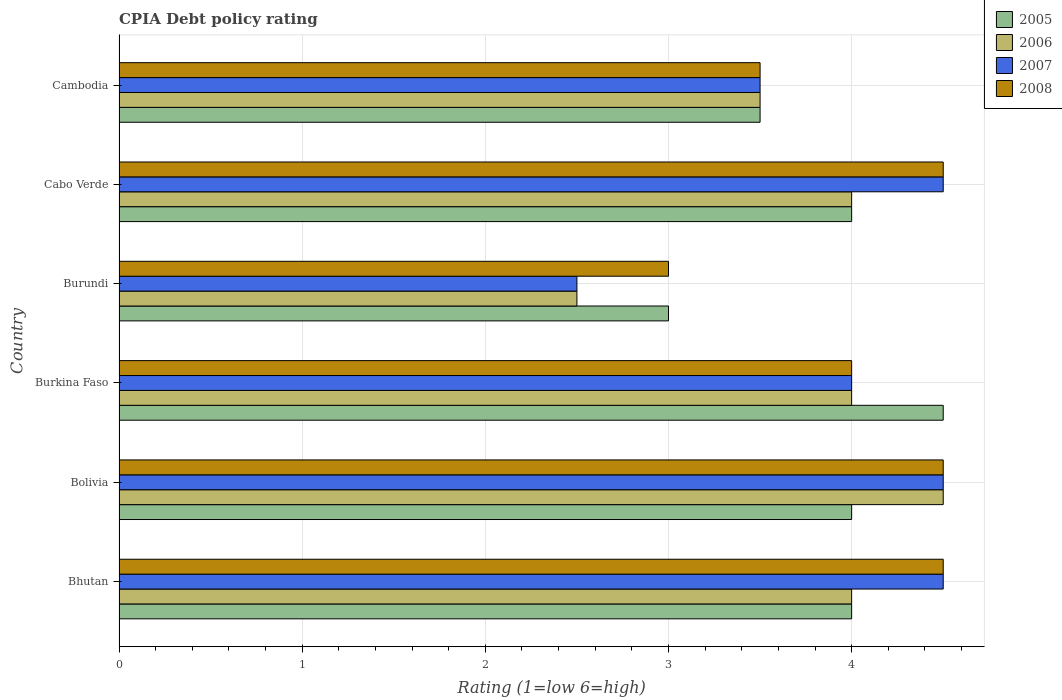How many different coloured bars are there?
Give a very brief answer. 4. Are the number of bars per tick equal to the number of legend labels?
Give a very brief answer. Yes. What is the label of the 1st group of bars from the top?
Give a very brief answer. Cambodia. In how many cases, is the number of bars for a given country not equal to the number of legend labels?
Give a very brief answer. 0. What is the CPIA rating in 2007 in Bolivia?
Keep it short and to the point. 4.5. Across all countries, what is the maximum CPIA rating in 2005?
Provide a short and direct response. 4.5. In which country was the CPIA rating in 2005 minimum?
Your answer should be compact. Burundi. What is the difference between the CPIA rating in 2008 in Burundi and that in Cambodia?
Ensure brevity in your answer.  -0.5. What is the difference between the CPIA rating in 2005 in Burundi and the CPIA rating in 2008 in Bolivia?
Make the answer very short. -1.5. What is the average CPIA rating in 2007 per country?
Ensure brevity in your answer.  3.92. What is the ratio of the CPIA rating in 2008 in Cabo Verde to that in Cambodia?
Your answer should be very brief. 1.29. Is the difference between the CPIA rating in 2008 in Bhutan and Burundi greater than the difference between the CPIA rating in 2007 in Bhutan and Burundi?
Your response must be concise. No. What is the difference between the highest and the lowest CPIA rating in 2005?
Offer a very short reply. 1.5. What does the 1st bar from the bottom in Burundi represents?
Your response must be concise. 2005. Is it the case that in every country, the sum of the CPIA rating in 2005 and CPIA rating in 2007 is greater than the CPIA rating in 2008?
Keep it short and to the point. Yes. Are all the bars in the graph horizontal?
Keep it short and to the point. Yes. Are the values on the major ticks of X-axis written in scientific E-notation?
Offer a very short reply. No. Where does the legend appear in the graph?
Your response must be concise. Top right. How are the legend labels stacked?
Offer a terse response. Vertical. What is the title of the graph?
Ensure brevity in your answer.  CPIA Debt policy rating. Does "2012" appear as one of the legend labels in the graph?
Your response must be concise. No. What is the label or title of the X-axis?
Offer a terse response. Rating (1=low 6=high). What is the Rating (1=low 6=high) in 2006 in Bhutan?
Offer a terse response. 4. What is the Rating (1=low 6=high) of 2007 in Bhutan?
Make the answer very short. 4.5. What is the Rating (1=low 6=high) of 2006 in Bolivia?
Make the answer very short. 4.5. What is the Rating (1=low 6=high) in 2007 in Bolivia?
Give a very brief answer. 4.5. What is the Rating (1=low 6=high) of 2008 in Bolivia?
Offer a terse response. 4.5. What is the Rating (1=low 6=high) in 2008 in Burkina Faso?
Make the answer very short. 4. What is the Rating (1=low 6=high) in 2005 in Burundi?
Give a very brief answer. 3. What is the Rating (1=low 6=high) in 2006 in Burundi?
Provide a succinct answer. 2.5. What is the Rating (1=low 6=high) of 2007 in Burundi?
Make the answer very short. 2.5. What is the Rating (1=low 6=high) in 2007 in Cabo Verde?
Provide a short and direct response. 4.5. What is the Rating (1=low 6=high) in 2008 in Cabo Verde?
Provide a short and direct response. 4.5. What is the Rating (1=low 6=high) of 2005 in Cambodia?
Offer a terse response. 3.5. What is the Rating (1=low 6=high) of 2006 in Cambodia?
Ensure brevity in your answer.  3.5. What is the Rating (1=low 6=high) in 2007 in Cambodia?
Keep it short and to the point. 3.5. What is the Rating (1=low 6=high) of 2008 in Cambodia?
Keep it short and to the point. 3.5. Across all countries, what is the maximum Rating (1=low 6=high) in 2007?
Make the answer very short. 4.5. Across all countries, what is the minimum Rating (1=low 6=high) of 2008?
Offer a terse response. 3. What is the total Rating (1=low 6=high) of 2007 in the graph?
Give a very brief answer. 23.5. What is the difference between the Rating (1=low 6=high) in 2005 in Bhutan and that in Bolivia?
Your answer should be compact. 0. What is the difference between the Rating (1=low 6=high) in 2006 in Bhutan and that in Bolivia?
Offer a very short reply. -0.5. What is the difference between the Rating (1=low 6=high) of 2005 in Bhutan and that in Burkina Faso?
Your answer should be very brief. -0.5. What is the difference between the Rating (1=low 6=high) in 2007 in Bhutan and that in Burkina Faso?
Offer a very short reply. 0.5. What is the difference between the Rating (1=low 6=high) of 2008 in Bhutan and that in Burkina Faso?
Your answer should be very brief. 0.5. What is the difference between the Rating (1=low 6=high) in 2005 in Bhutan and that in Burundi?
Ensure brevity in your answer.  1. What is the difference between the Rating (1=low 6=high) of 2008 in Bhutan and that in Burundi?
Give a very brief answer. 1.5. What is the difference between the Rating (1=low 6=high) in 2007 in Bhutan and that in Cabo Verde?
Your response must be concise. 0. What is the difference between the Rating (1=low 6=high) in 2006 in Bhutan and that in Cambodia?
Your answer should be very brief. 0.5. What is the difference between the Rating (1=low 6=high) of 2007 in Bolivia and that in Burkina Faso?
Your response must be concise. 0.5. What is the difference between the Rating (1=low 6=high) in 2008 in Bolivia and that in Burkina Faso?
Your response must be concise. 0.5. What is the difference between the Rating (1=low 6=high) in 2005 in Bolivia and that in Burundi?
Provide a short and direct response. 1. What is the difference between the Rating (1=low 6=high) of 2006 in Bolivia and that in Burundi?
Your response must be concise. 2. What is the difference between the Rating (1=low 6=high) of 2007 in Bolivia and that in Cabo Verde?
Keep it short and to the point. 0. What is the difference between the Rating (1=low 6=high) in 2008 in Bolivia and that in Cabo Verde?
Offer a very short reply. 0. What is the difference between the Rating (1=low 6=high) of 2007 in Bolivia and that in Cambodia?
Keep it short and to the point. 1. What is the difference between the Rating (1=low 6=high) in 2008 in Bolivia and that in Cambodia?
Provide a short and direct response. 1. What is the difference between the Rating (1=low 6=high) in 2007 in Burkina Faso and that in Burundi?
Provide a succinct answer. 1.5. What is the difference between the Rating (1=low 6=high) of 2006 in Burkina Faso and that in Cabo Verde?
Your answer should be compact. 0. What is the difference between the Rating (1=low 6=high) of 2008 in Burkina Faso and that in Cabo Verde?
Provide a short and direct response. -0.5. What is the difference between the Rating (1=low 6=high) in 2006 in Burkina Faso and that in Cambodia?
Provide a short and direct response. 0.5. What is the difference between the Rating (1=low 6=high) of 2007 in Burkina Faso and that in Cambodia?
Make the answer very short. 0.5. What is the difference between the Rating (1=low 6=high) of 2005 in Burundi and that in Cabo Verde?
Keep it short and to the point. -1. What is the difference between the Rating (1=low 6=high) in 2006 in Burundi and that in Cabo Verde?
Ensure brevity in your answer.  -1.5. What is the difference between the Rating (1=low 6=high) of 2007 in Burundi and that in Cabo Verde?
Provide a succinct answer. -2. What is the difference between the Rating (1=low 6=high) of 2008 in Burundi and that in Cabo Verde?
Your answer should be compact. -1.5. What is the difference between the Rating (1=low 6=high) of 2006 in Burundi and that in Cambodia?
Give a very brief answer. -1. What is the difference between the Rating (1=low 6=high) in 2008 in Burundi and that in Cambodia?
Ensure brevity in your answer.  -0.5. What is the difference between the Rating (1=low 6=high) in 2005 in Cabo Verde and that in Cambodia?
Provide a short and direct response. 0.5. What is the difference between the Rating (1=low 6=high) in 2007 in Cabo Verde and that in Cambodia?
Provide a short and direct response. 1. What is the difference between the Rating (1=low 6=high) in 2008 in Cabo Verde and that in Cambodia?
Your response must be concise. 1. What is the difference between the Rating (1=low 6=high) in 2006 in Bhutan and the Rating (1=low 6=high) in 2007 in Bolivia?
Provide a short and direct response. -0.5. What is the difference between the Rating (1=low 6=high) in 2007 in Bhutan and the Rating (1=low 6=high) in 2008 in Bolivia?
Your answer should be compact. 0. What is the difference between the Rating (1=low 6=high) in 2005 in Bhutan and the Rating (1=low 6=high) in 2006 in Burkina Faso?
Offer a terse response. 0. What is the difference between the Rating (1=low 6=high) in 2005 in Bhutan and the Rating (1=low 6=high) in 2007 in Burkina Faso?
Offer a very short reply. 0. What is the difference between the Rating (1=low 6=high) of 2006 in Bhutan and the Rating (1=low 6=high) of 2007 in Burkina Faso?
Offer a terse response. 0. What is the difference between the Rating (1=low 6=high) of 2007 in Bhutan and the Rating (1=low 6=high) of 2008 in Burkina Faso?
Keep it short and to the point. 0.5. What is the difference between the Rating (1=low 6=high) in 2005 in Bhutan and the Rating (1=low 6=high) in 2007 in Burundi?
Ensure brevity in your answer.  1.5. What is the difference between the Rating (1=low 6=high) in 2005 in Bhutan and the Rating (1=low 6=high) in 2008 in Burundi?
Give a very brief answer. 1. What is the difference between the Rating (1=low 6=high) of 2006 in Bhutan and the Rating (1=low 6=high) of 2007 in Burundi?
Give a very brief answer. 1.5. What is the difference between the Rating (1=low 6=high) of 2006 in Bhutan and the Rating (1=low 6=high) of 2008 in Burundi?
Provide a short and direct response. 1. What is the difference between the Rating (1=low 6=high) of 2007 in Bhutan and the Rating (1=low 6=high) of 2008 in Burundi?
Keep it short and to the point. 1.5. What is the difference between the Rating (1=low 6=high) of 2005 in Bhutan and the Rating (1=low 6=high) of 2006 in Cabo Verde?
Your answer should be compact. 0. What is the difference between the Rating (1=low 6=high) in 2006 in Bhutan and the Rating (1=low 6=high) in 2007 in Cabo Verde?
Your answer should be very brief. -0.5. What is the difference between the Rating (1=low 6=high) of 2006 in Bhutan and the Rating (1=low 6=high) of 2008 in Cabo Verde?
Give a very brief answer. -0.5. What is the difference between the Rating (1=low 6=high) in 2005 in Bhutan and the Rating (1=low 6=high) in 2006 in Cambodia?
Offer a very short reply. 0.5. What is the difference between the Rating (1=low 6=high) in 2005 in Bhutan and the Rating (1=low 6=high) in 2008 in Cambodia?
Make the answer very short. 0.5. What is the difference between the Rating (1=low 6=high) of 2007 in Bhutan and the Rating (1=low 6=high) of 2008 in Cambodia?
Offer a very short reply. 1. What is the difference between the Rating (1=low 6=high) of 2005 in Bolivia and the Rating (1=low 6=high) of 2006 in Burkina Faso?
Your answer should be very brief. 0. What is the difference between the Rating (1=low 6=high) of 2006 in Bolivia and the Rating (1=low 6=high) of 2007 in Burkina Faso?
Your answer should be very brief. 0.5. What is the difference between the Rating (1=low 6=high) of 2005 in Bolivia and the Rating (1=low 6=high) of 2008 in Burundi?
Your answer should be very brief. 1. What is the difference between the Rating (1=low 6=high) of 2007 in Bolivia and the Rating (1=low 6=high) of 2008 in Burundi?
Make the answer very short. 1.5. What is the difference between the Rating (1=low 6=high) of 2005 in Bolivia and the Rating (1=low 6=high) of 2008 in Cabo Verde?
Offer a terse response. -0.5. What is the difference between the Rating (1=low 6=high) of 2006 in Bolivia and the Rating (1=low 6=high) of 2007 in Cabo Verde?
Provide a succinct answer. 0. What is the difference between the Rating (1=low 6=high) of 2006 in Bolivia and the Rating (1=low 6=high) of 2008 in Cabo Verde?
Your answer should be very brief. 0. What is the difference between the Rating (1=low 6=high) in 2005 in Bolivia and the Rating (1=low 6=high) in 2006 in Cambodia?
Provide a succinct answer. 0.5. What is the difference between the Rating (1=low 6=high) of 2005 in Bolivia and the Rating (1=low 6=high) of 2007 in Cambodia?
Provide a short and direct response. 0.5. What is the difference between the Rating (1=low 6=high) of 2005 in Bolivia and the Rating (1=low 6=high) of 2008 in Cambodia?
Keep it short and to the point. 0.5. What is the difference between the Rating (1=low 6=high) of 2006 in Bolivia and the Rating (1=low 6=high) of 2007 in Cambodia?
Offer a terse response. 1. What is the difference between the Rating (1=low 6=high) in 2007 in Bolivia and the Rating (1=low 6=high) in 2008 in Cambodia?
Keep it short and to the point. 1. What is the difference between the Rating (1=low 6=high) in 2007 in Burkina Faso and the Rating (1=low 6=high) in 2008 in Burundi?
Keep it short and to the point. 1. What is the difference between the Rating (1=low 6=high) in 2005 in Burkina Faso and the Rating (1=low 6=high) in 2006 in Cabo Verde?
Your response must be concise. 0.5. What is the difference between the Rating (1=low 6=high) of 2006 in Burkina Faso and the Rating (1=low 6=high) of 2007 in Cabo Verde?
Provide a succinct answer. -0.5. What is the difference between the Rating (1=low 6=high) in 2006 in Burkina Faso and the Rating (1=low 6=high) in 2008 in Cabo Verde?
Provide a succinct answer. -0.5. What is the difference between the Rating (1=low 6=high) of 2005 in Burkina Faso and the Rating (1=low 6=high) of 2007 in Cambodia?
Give a very brief answer. 1. What is the difference between the Rating (1=low 6=high) of 2006 in Burkina Faso and the Rating (1=low 6=high) of 2008 in Cambodia?
Your answer should be very brief. 0.5. What is the difference between the Rating (1=low 6=high) of 2005 in Burundi and the Rating (1=low 6=high) of 2006 in Cabo Verde?
Offer a terse response. -1. What is the difference between the Rating (1=low 6=high) in 2005 in Burundi and the Rating (1=low 6=high) in 2007 in Cambodia?
Provide a short and direct response. -0.5. What is the difference between the Rating (1=low 6=high) in 2006 in Burundi and the Rating (1=low 6=high) in 2007 in Cambodia?
Offer a terse response. -1. What is the difference between the Rating (1=low 6=high) in 2006 in Burundi and the Rating (1=low 6=high) in 2008 in Cambodia?
Give a very brief answer. -1. What is the difference between the Rating (1=low 6=high) in 2007 in Burundi and the Rating (1=low 6=high) in 2008 in Cambodia?
Make the answer very short. -1. What is the average Rating (1=low 6=high) of 2005 per country?
Ensure brevity in your answer.  3.83. What is the average Rating (1=low 6=high) in 2006 per country?
Give a very brief answer. 3.75. What is the average Rating (1=low 6=high) of 2007 per country?
Provide a short and direct response. 3.92. What is the difference between the Rating (1=low 6=high) of 2005 and Rating (1=low 6=high) of 2007 in Bhutan?
Give a very brief answer. -0.5. What is the difference between the Rating (1=low 6=high) in 2006 and Rating (1=low 6=high) in 2007 in Bhutan?
Provide a succinct answer. -0.5. What is the difference between the Rating (1=low 6=high) of 2005 and Rating (1=low 6=high) of 2006 in Bolivia?
Ensure brevity in your answer.  -0.5. What is the difference between the Rating (1=low 6=high) of 2005 and Rating (1=low 6=high) of 2007 in Bolivia?
Offer a terse response. -0.5. What is the difference between the Rating (1=low 6=high) in 2005 and Rating (1=low 6=high) in 2008 in Bolivia?
Offer a terse response. -0.5. What is the difference between the Rating (1=low 6=high) in 2006 and Rating (1=low 6=high) in 2007 in Bolivia?
Provide a short and direct response. 0. What is the difference between the Rating (1=low 6=high) in 2007 and Rating (1=low 6=high) in 2008 in Bolivia?
Your answer should be compact. 0. What is the difference between the Rating (1=low 6=high) of 2005 and Rating (1=low 6=high) of 2008 in Burkina Faso?
Keep it short and to the point. 0.5. What is the difference between the Rating (1=low 6=high) of 2006 and Rating (1=low 6=high) of 2007 in Burkina Faso?
Your answer should be compact. 0. What is the difference between the Rating (1=low 6=high) in 2007 and Rating (1=low 6=high) in 2008 in Burkina Faso?
Your answer should be compact. 0. What is the difference between the Rating (1=low 6=high) in 2005 and Rating (1=low 6=high) in 2006 in Burundi?
Keep it short and to the point. 0.5. What is the difference between the Rating (1=low 6=high) of 2005 and Rating (1=low 6=high) of 2008 in Burundi?
Your response must be concise. 0. What is the difference between the Rating (1=low 6=high) of 2006 and Rating (1=low 6=high) of 2008 in Burundi?
Keep it short and to the point. -0.5. What is the difference between the Rating (1=low 6=high) of 2005 and Rating (1=low 6=high) of 2007 in Cambodia?
Keep it short and to the point. 0. What is the difference between the Rating (1=low 6=high) of 2005 and Rating (1=low 6=high) of 2008 in Cambodia?
Offer a terse response. 0. What is the difference between the Rating (1=low 6=high) in 2006 and Rating (1=low 6=high) in 2008 in Cambodia?
Make the answer very short. 0. What is the ratio of the Rating (1=low 6=high) in 2007 in Bhutan to that in Bolivia?
Your response must be concise. 1. What is the ratio of the Rating (1=low 6=high) of 2008 in Bhutan to that in Bolivia?
Provide a short and direct response. 1. What is the ratio of the Rating (1=low 6=high) of 2007 in Bhutan to that in Burkina Faso?
Provide a succinct answer. 1.12. What is the ratio of the Rating (1=low 6=high) in 2008 in Bhutan to that in Burkina Faso?
Give a very brief answer. 1.12. What is the ratio of the Rating (1=low 6=high) of 2005 in Bhutan to that in Burundi?
Offer a very short reply. 1.33. What is the ratio of the Rating (1=low 6=high) of 2005 in Bhutan to that in Cabo Verde?
Provide a succinct answer. 1. What is the ratio of the Rating (1=low 6=high) in 2007 in Bhutan to that in Cabo Verde?
Offer a very short reply. 1. What is the ratio of the Rating (1=low 6=high) of 2007 in Bhutan to that in Cambodia?
Your response must be concise. 1.29. What is the ratio of the Rating (1=low 6=high) in 2005 in Bolivia to that in Burkina Faso?
Your answer should be compact. 0.89. What is the ratio of the Rating (1=low 6=high) in 2006 in Bolivia to that in Burkina Faso?
Offer a very short reply. 1.12. What is the ratio of the Rating (1=low 6=high) in 2007 in Bolivia to that in Burkina Faso?
Provide a succinct answer. 1.12. What is the ratio of the Rating (1=low 6=high) of 2006 in Bolivia to that in Burundi?
Keep it short and to the point. 1.8. What is the ratio of the Rating (1=low 6=high) of 2008 in Bolivia to that in Burundi?
Give a very brief answer. 1.5. What is the ratio of the Rating (1=low 6=high) of 2005 in Bolivia to that in Cabo Verde?
Your answer should be compact. 1. What is the ratio of the Rating (1=low 6=high) of 2006 in Bolivia to that in Cambodia?
Your answer should be very brief. 1.29. What is the ratio of the Rating (1=low 6=high) of 2006 in Burkina Faso to that in Burundi?
Your answer should be very brief. 1.6. What is the ratio of the Rating (1=low 6=high) in 2007 in Burkina Faso to that in Cabo Verde?
Make the answer very short. 0.89. What is the ratio of the Rating (1=low 6=high) of 2006 in Burkina Faso to that in Cambodia?
Offer a terse response. 1.14. What is the ratio of the Rating (1=low 6=high) in 2007 in Burkina Faso to that in Cambodia?
Offer a terse response. 1.14. What is the ratio of the Rating (1=low 6=high) in 2006 in Burundi to that in Cabo Verde?
Ensure brevity in your answer.  0.62. What is the ratio of the Rating (1=low 6=high) of 2007 in Burundi to that in Cabo Verde?
Provide a succinct answer. 0.56. What is the ratio of the Rating (1=low 6=high) of 2005 in Burundi to that in Cambodia?
Offer a very short reply. 0.86. What is the ratio of the Rating (1=low 6=high) of 2006 in Burundi to that in Cambodia?
Ensure brevity in your answer.  0.71. What is the ratio of the Rating (1=low 6=high) of 2008 in Burundi to that in Cambodia?
Offer a terse response. 0.86. What is the difference between the highest and the second highest Rating (1=low 6=high) of 2007?
Provide a succinct answer. 0. What is the difference between the highest and the second highest Rating (1=low 6=high) of 2008?
Offer a very short reply. 0. What is the difference between the highest and the lowest Rating (1=low 6=high) of 2005?
Give a very brief answer. 1.5. What is the difference between the highest and the lowest Rating (1=low 6=high) of 2006?
Provide a succinct answer. 2. What is the difference between the highest and the lowest Rating (1=low 6=high) of 2007?
Make the answer very short. 2. What is the difference between the highest and the lowest Rating (1=low 6=high) in 2008?
Offer a very short reply. 1.5. 